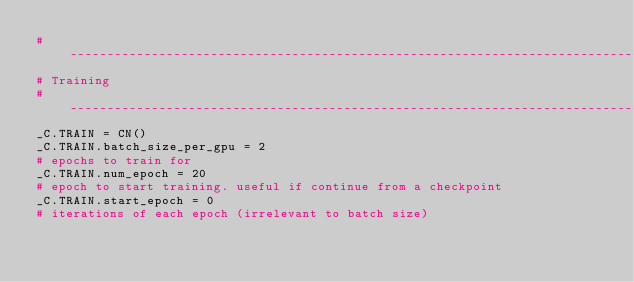<code> <loc_0><loc_0><loc_500><loc_500><_Python_># -----------------------------------------------------------------------------
# Training
# -----------------------------------------------------------------------------
_C.TRAIN = CN()
_C.TRAIN.batch_size_per_gpu = 2
# epochs to train for
_C.TRAIN.num_epoch = 20
# epoch to start training. useful if continue from a checkpoint
_C.TRAIN.start_epoch = 0
# iterations of each epoch (irrelevant to batch size)</code> 